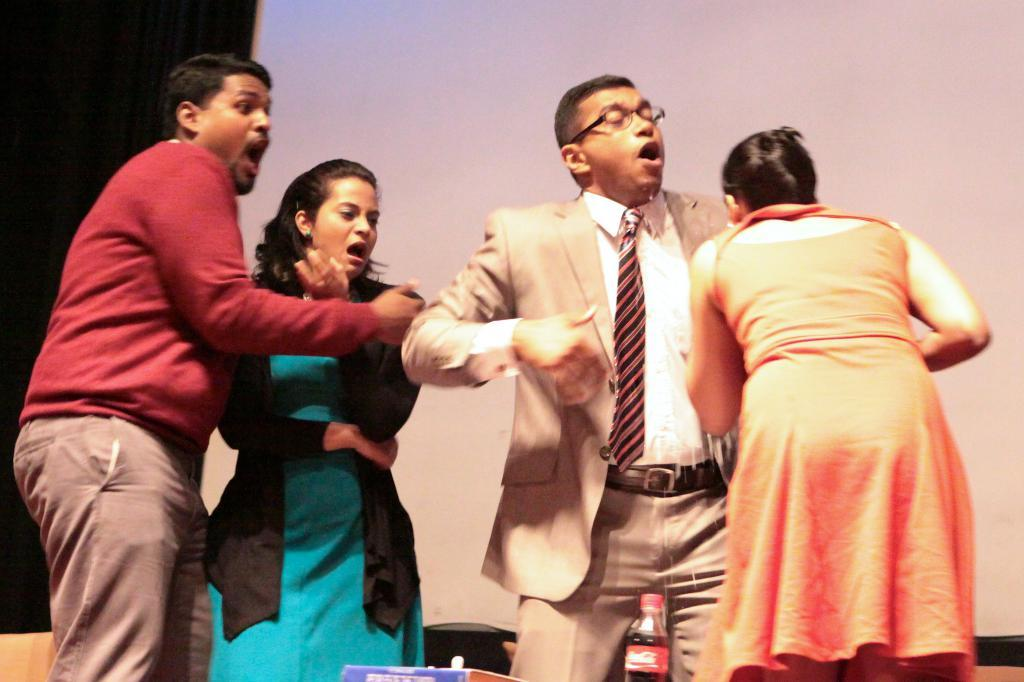How many people are in the image? There are four persons in the image. What can be observed about their clothing? The persons are wearing different color dresses. What are the persons doing in the image? The persons are standing, and three of them are getting excited. Can you describe the background of the image? There is a white colored cloth in the background. What type of battle is taking place in the image? There is no battle present in the image; it features four persons wearing different color dresses and standing. Can you tell me how many breaths the person in the blue shirt is taking in the image? There is no mention of a blue shirt or counting breaths in the image; it only describes the persons wearing different color dresses. 